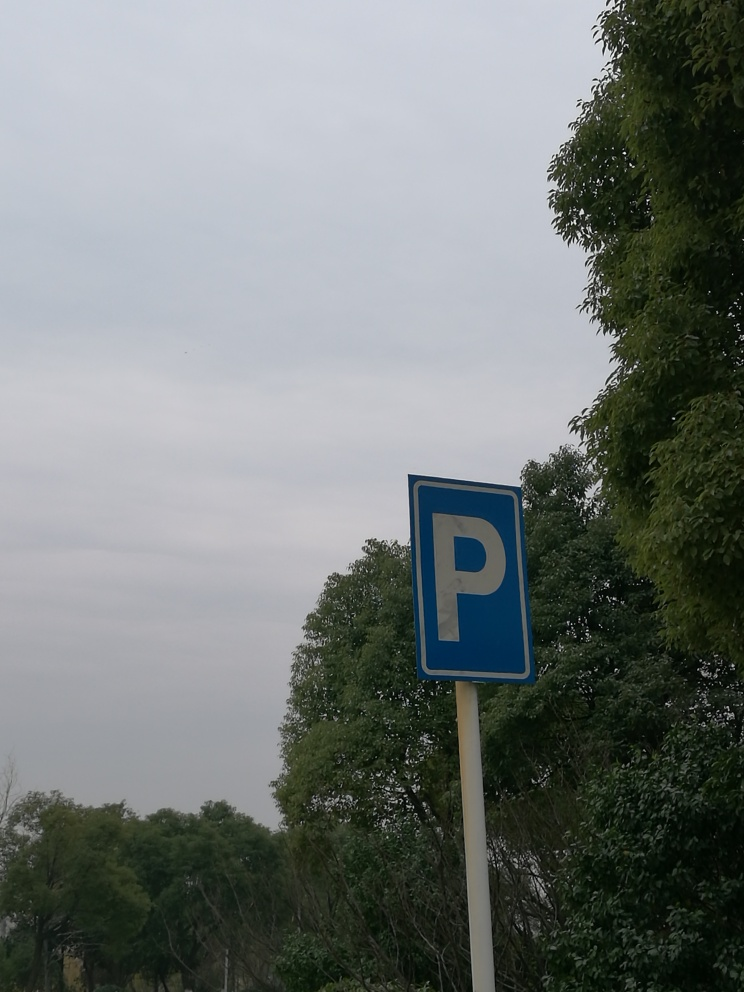Is there any distortion in the image?
A. No specific distortion
B. Distorted image
C. Distortion present
D. Some distortion
Answer with the option's letter from the given choices directly.
 A. 